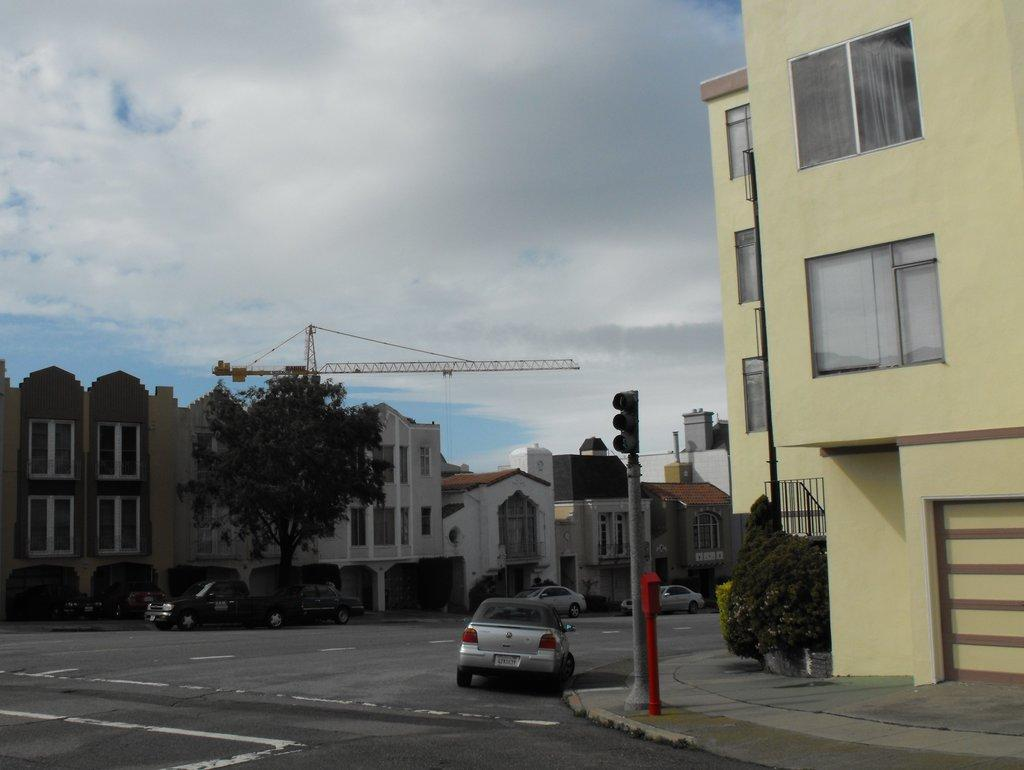What type of structures can be seen in the image? There are buildings in the image. What other natural elements are present in the image? There are trees in the image. What type of vehicles can be seen in the image? There are cars in the image. What construction equipment is visible in the image? There is a crane in the image. How would you describe the sky in the image? The sky is blue and cloudy in the image. What type of traffic control device is present in the image? There is a traffic signal on a pole in the image. What is the relation between the cars and the crane in the image? There is no specific relation between the cars and the crane mentioned in the image; they are simply separate elements in the scene. What impulse caused the traffic signal to change colors in the image? The traffic signal's color change is not related to any impulse in the image; it is likely controlled by a timer or sensor. 